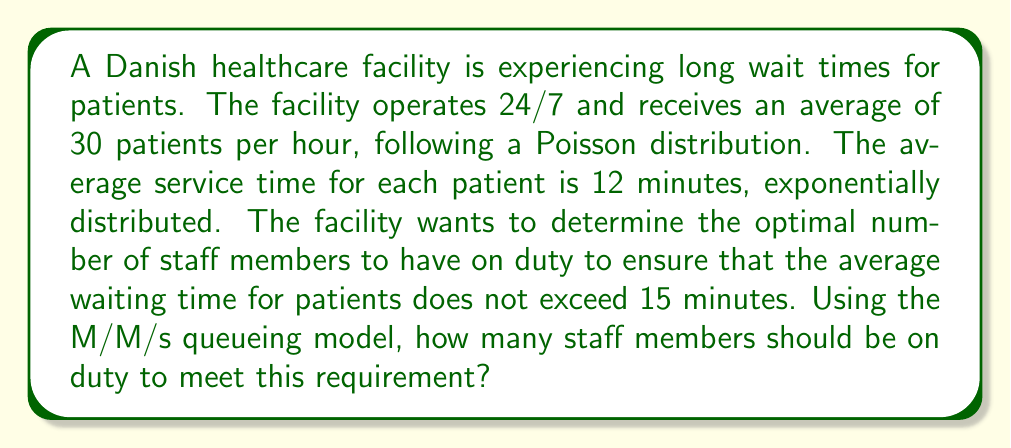Can you answer this question? To solve this problem, we'll use the M/M/s queueing model, where:

M/M/s represents:
- M: Markovian arrival process (Poisson)
- M: Markovian service times (exponential)
- s: Number of servers (staff members)

Given:
- Arrival rate: $\lambda = 30$ patients/hour
- Service rate: $\mu = 60/12 = 5$ patients/hour per staff member
- Maximum average waiting time: $W_q = 15$ minutes = 0.25 hours

Step 1: Calculate the utilization factor $\rho = \frac{\lambda}{s\mu}$

Step 2: Use the Erlang C formula to calculate the probability of waiting:

$$ P_q = \frac{(s\rho)^s}{s!(1-\rho)} \cdot \left[\sum_{n=0}^{s-1}\frac{(s\rho)^n}{n!} + \frac{(s\rho)^s}{s!(1-\rho)}\right]^{-1} $$

Step 3: Calculate the average waiting time:

$$ W_q = \frac{P_q}{s\mu - \lambda} $$

Step 4: Iterate through different values of s until $W_q \leq 0.25$ hours

Using a computer program or spreadsheet to perform these calculations, we find:

For s = 7:
$\rho = 0.8571$
$P_q = 0.7808$
$W_q = 0.3123$ hours (exceeds the limit)

For s = 8:
$\rho = 0.7500$
$P_q = 0.5984$
$W_q = 0.1993$ hours (meets the requirement)

Therefore, the minimum number of staff members needed is 8.
Answer: 8 staff members 